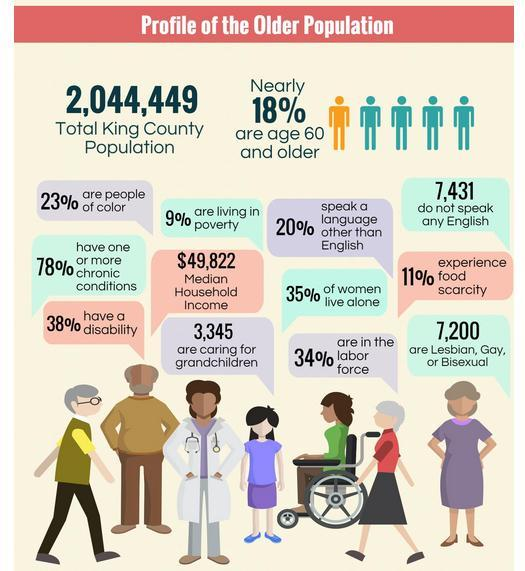What percentage of women not live alone?
Answer the question with a short phrase. 65% What percentage are people of not color? 77% What percentage didn't have a disability? 62% What percentage are not living in poverty? 91% What percentage of people did not experience food scarcity? 89% What percentage of people are not in the labor force? 66% 